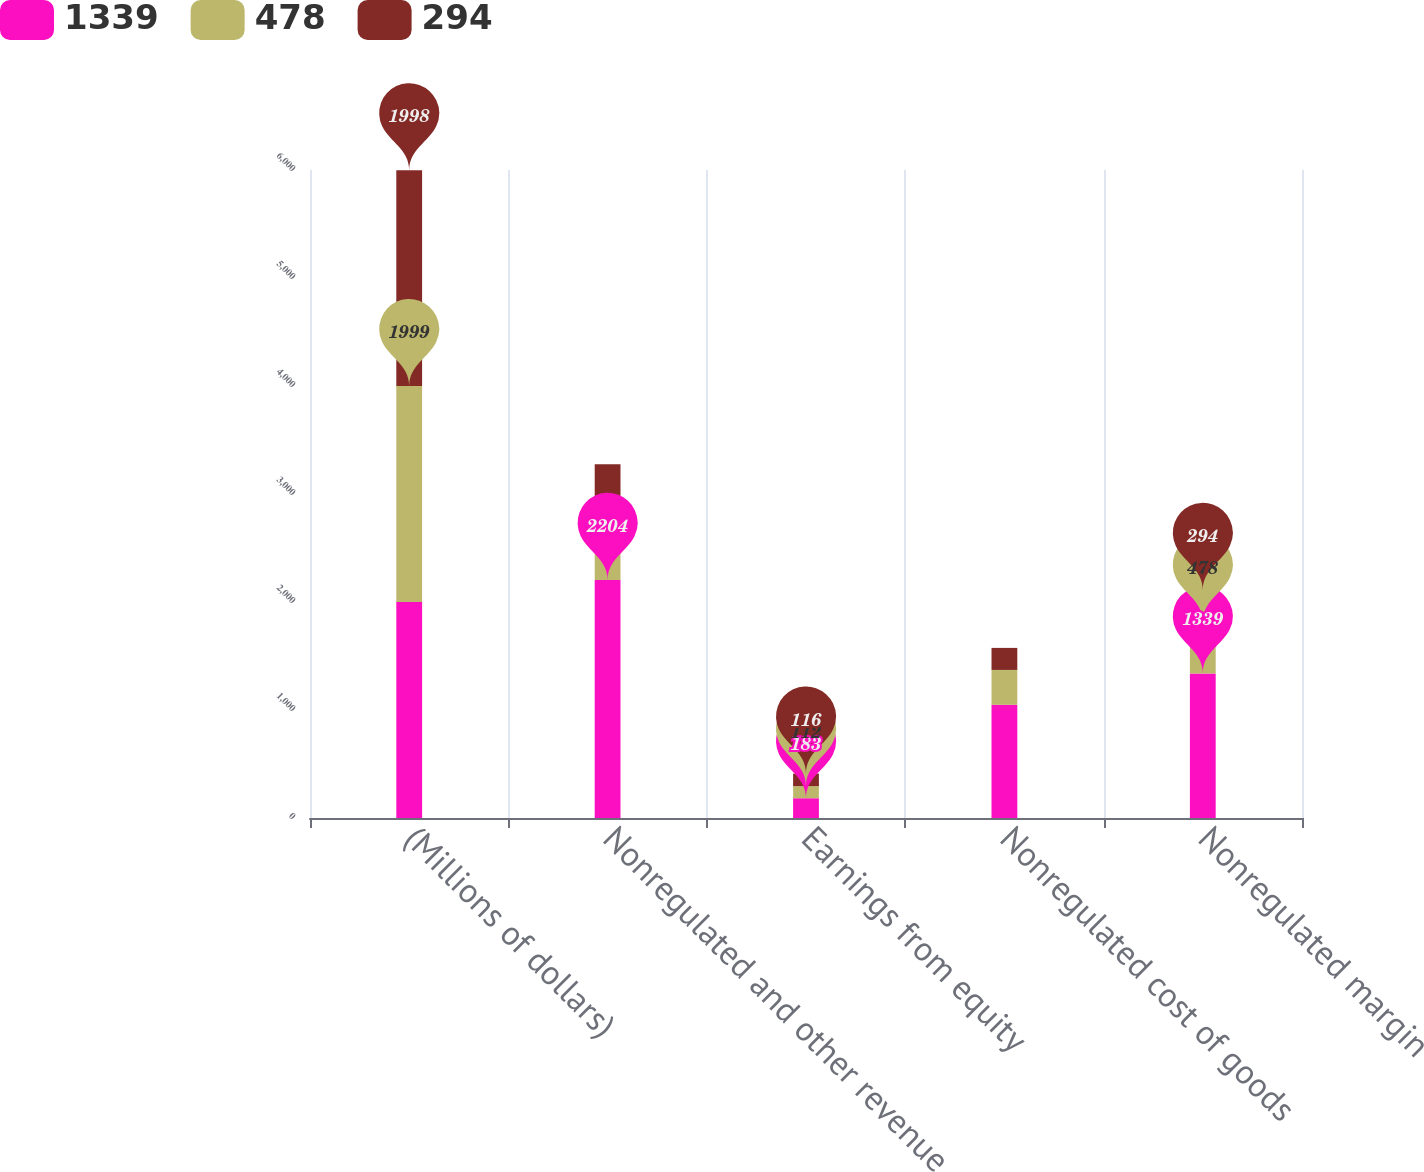Convert chart to OTSL. <chart><loc_0><loc_0><loc_500><loc_500><stacked_bar_chart><ecel><fcel>(Millions of dollars)<fcel>Nonregulated and other revenue<fcel>Earnings from equity<fcel>Nonregulated cost of goods<fcel>Nonregulated margin<nl><fcel>1339<fcel>2000<fcel>2204<fcel>183<fcel>1048<fcel>1339<nl><fcel>478<fcel>1999<fcel>689<fcel>112<fcel>323<fcel>478<nl><fcel>294<fcel>1998<fcel>382<fcel>116<fcel>204<fcel>294<nl></chart> 